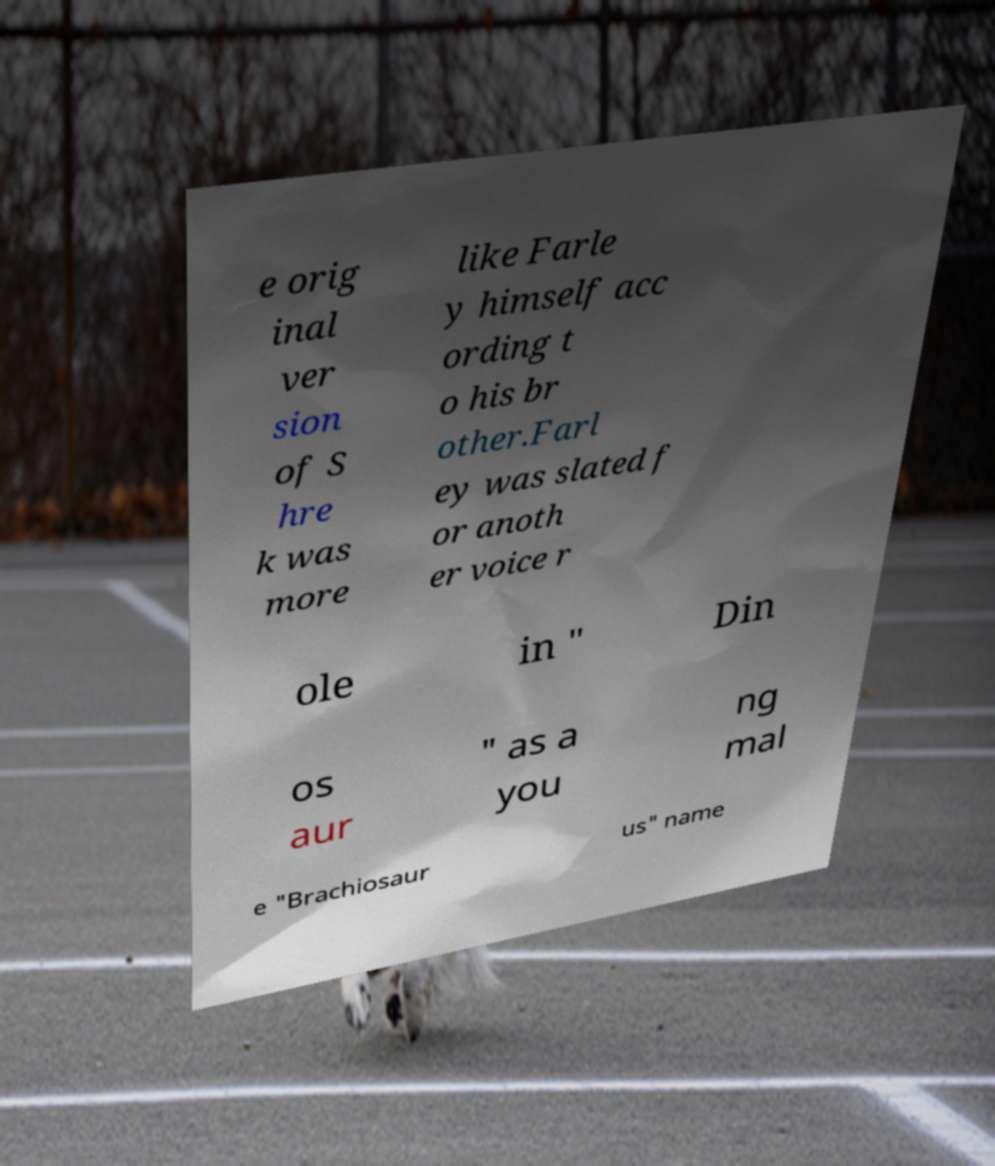There's text embedded in this image that I need extracted. Can you transcribe it verbatim? e orig inal ver sion of S hre k was more like Farle y himself acc ording t o his br other.Farl ey was slated f or anoth er voice r ole in " Din os aur " as a you ng mal e "Brachiosaur us" name 